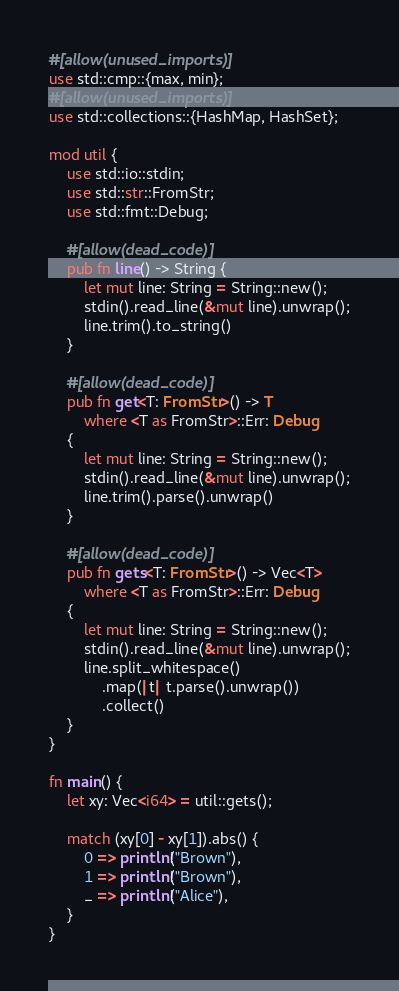<code> <loc_0><loc_0><loc_500><loc_500><_Rust_>#[allow(unused_imports)]
use std::cmp::{max, min};
#[allow(unused_imports)]
use std::collections::{HashMap, HashSet};

mod util {
    use std::io::stdin;
    use std::str::FromStr;
    use std::fmt::Debug;

    #[allow(dead_code)]
    pub fn line() -> String {
        let mut line: String = String::new();
        stdin().read_line(&mut line).unwrap();
        line.trim().to_string()
    }

    #[allow(dead_code)]
    pub fn get<T: FromStr>() -> T
        where <T as FromStr>::Err: Debug
    {
        let mut line: String = String::new();
        stdin().read_line(&mut line).unwrap();
        line.trim().parse().unwrap()
    }

    #[allow(dead_code)]
    pub fn gets<T: FromStr>() -> Vec<T>
        where <T as FromStr>::Err: Debug
    {
        let mut line: String = String::new();
        stdin().read_line(&mut line).unwrap();
        line.split_whitespace()
            .map(|t| t.parse().unwrap())
            .collect()
    }
}

fn main() {
    let xy: Vec<i64> = util::gets();

    match (xy[0] - xy[1]).abs() {
        0 => println!("Brown"),
        1 => println!("Brown"),
        _ => println!("Alice"),
    }
}
</code> 